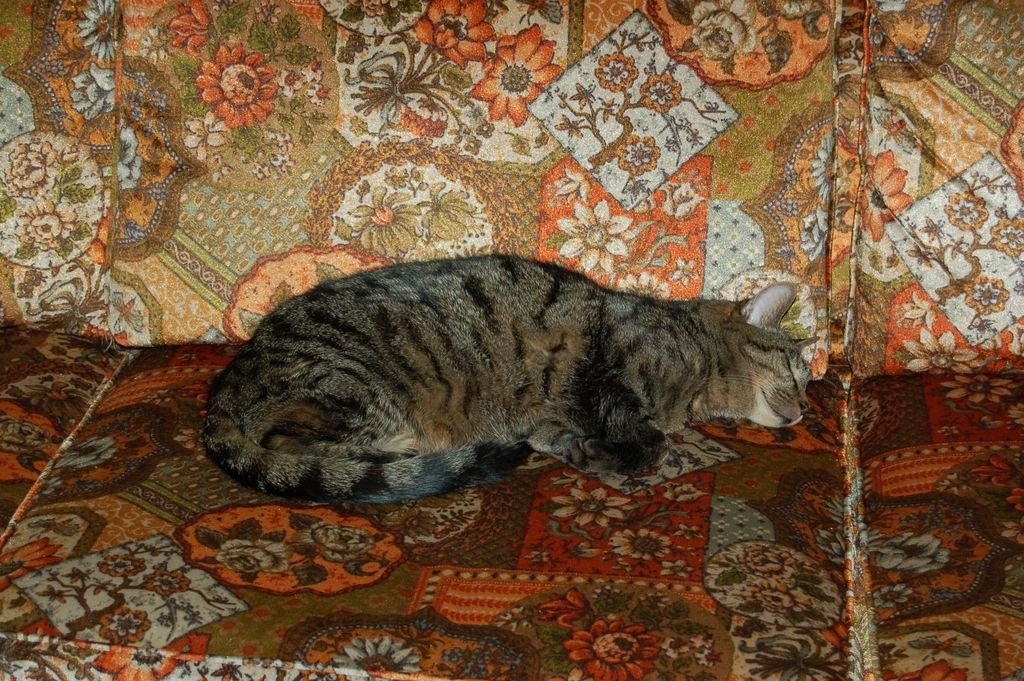What type of animal is in the image? There is a cat in the image. What is the cat doing in the image? The cat is sleeping on a couch. Can you describe the coloring of the cat? The cat has black and gray coloring. What type of apple is on the cat's head in the image? There is no apple present in the image, and the cat's head is not mentioned in the provided facts. 